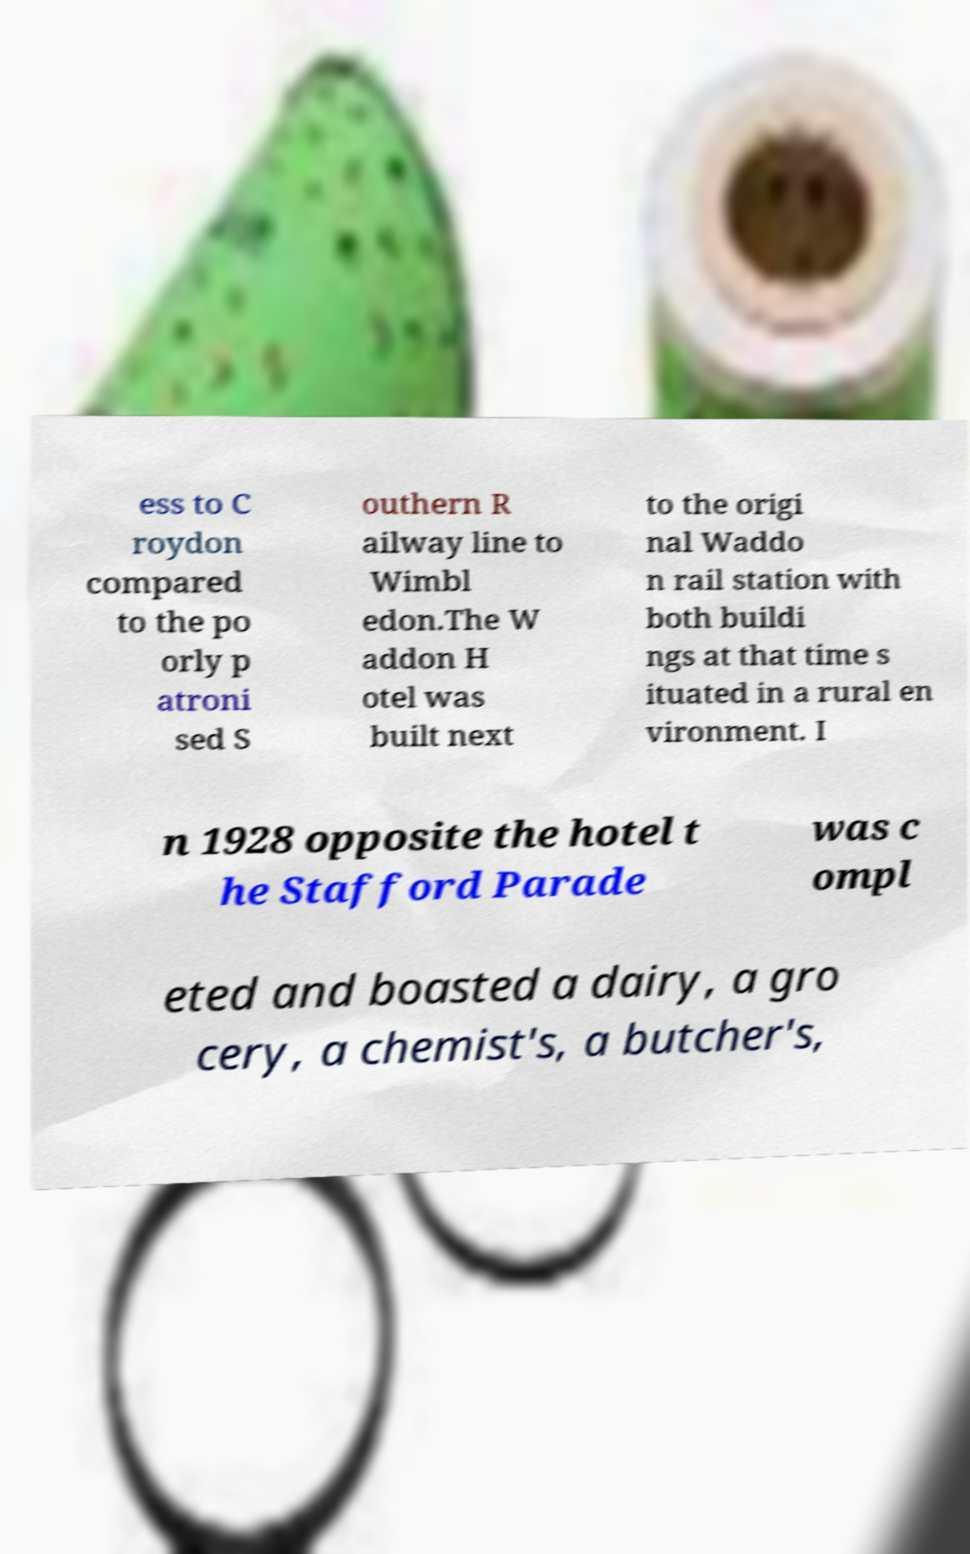Can you read and provide the text displayed in the image?This photo seems to have some interesting text. Can you extract and type it out for me? ess to C roydon compared to the po orly p atroni sed S outhern R ailway line to Wimbl edon.The W addon H otel was built next to the origi nal Waddo n rail station with both buildi ngs at that time s ituated in a rural en vironment. I n 1928 opposite the hotel t he Stafford Parade was c ompl eted and boasted a dairy, a gro cery, a chemist's, a butcher's, 